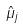Convert formula to latex. <formula><loc_0><loc_0><loc_500><loc_500>\hat { \mu } _ { j }</formula> 